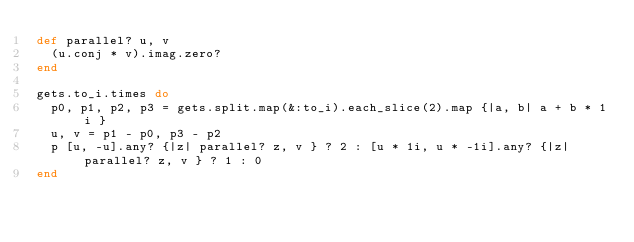Convert code to text. <code><loc_0><loc_0><loc_500><loc_500><_Ruby_>def parallel? u, v
  (u.conj * v).imag.zero?
end

gets.to_i.times do
  p0, p1, p2, p3 = gets.split.map(&:to_i).each_slice(2).map {|a, b| a + b * 1i }
  u, v = p1 - p0, p3 - p2
  p [u, -u].any? {|z| parallel? z, v } ? 2 : [u * 1i, u * -1i].any? {|z| parallel? z, v } ? 1 : 0
end</code> 